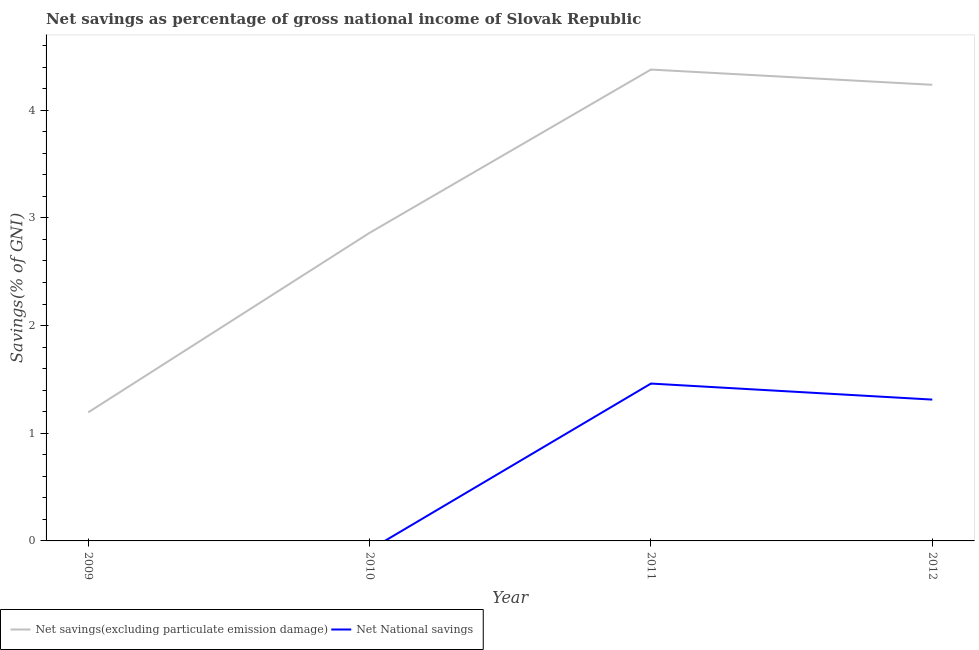What is the net national savings in 2011?
Keep it short and to the point. 1.46. Across all years, what is the maximum net national savings?
Offer a very short reply. 1.46. Across all years, what is the minimum net national savings?
Provide a short and direct response. 0. In which year was the net national savings maximum?
Your answer should be very brief. 2011. What is the total net savings(excluding particulate emission damage) in the graph?
Provide a succinct answer. 12.67. What is the difference between the net savings(excluding particulate emission damage) in 2011 and that in 2012?
Offer a very short reply. 0.14. What is the difference between the net national savings in 2011 and the net savings(excluding particulate emission damage) in 2009?
Your response must be concise. 0.27. What is the average net national savings per year?
Provide a succinct answer. 0.69. In the year 2011, what is the difference between the net savings(excluding particulate emission damage) and net national savings?
Your answer should be very brief. 2.92. In how many years, is the net national savings greater than 3.2 %?
Offer a very short reply. 0. What is the ratio of the net savings(excluding particulate emission damage) in 2009 to that in 2010?
Provide a succinct answer. 0.42. What is the difference between the highest and the second highest net savings(excluding particulate emission damage)?
Your response must be concise. 0.14. What is the difference between the highest and the lowest net savings(excluding particulate emission damage)?
Ensure brevity in your answer.  3.18. In how many years, is the net savings(excluding particulate emission damage) greater than the average net savings(excluding particulate emission damage) taken over all years?
Provide a succinct answer. 2. Is the net savings(excluding particulate emission damage) strictly greater than the net national savings over the years?
Ensure brevity in your answer.  Yes. Is the net national savings strictly less than the net savings(excluding particulate emission damage) over the years?
Give a very brief answer. Yes. What is the difference between two consecutive major ticks on the Y-axis?
Offer a terse response. 1. Are the values on the major ticks of Y-axis written in scientific E-notation?
Keep it short and to the point. No. Does the graph contain any zero values?
Keep it short and to the point. Yes. Does the graph contain grids?
Your answer should be very brief. No. How many legend labels are there?
Make the answer very short. 2. What is the title of the graph?
Your answer should be compact. Net savings as percentage of gross national income of Slovak Republic. Does "Pregnant women" appear as one of the legend labels in the graph?
Keep it short and to the point. No. What is the label or title of the X-axis?
Your answer should be very brief. Year. What is the label or title of the Y-axis?
Give a very brief answer. Savings(% of GNI). What is the Savings(% of GNI) of Net savings(excluding particulate emission damage) in 2009?
Provide a short and direct response. 1.19. What is the Savings(% of GNI) in Net National savings in 2009?
Make the answer very short. 0. What is the Savings(% of GNI) in Net savings(excluding particulate emission damage) in 2010?
Your response must be concise. 2.86. What is the Savings(% of GNI) of Net savings(excluding particulate emission damage) in 2011?
Make the answer very short. 4.38. What is the Savings(% of GNI) of Net National savings in 2011?
Provide a succinct answer. 1.46. What is the Savings(% of GNI) of Net savings(excluding particulate emission damage) in 2012?
Make the answer very short. 4.24. What is the Savings(% of GNI) in Net National savings in 2012?
Offer a terse response. 1.31. Across all years, what is the maximum Savings(% of GNI) in Net savings(excluding particulate emission damage)?
Ensure brevity in your answer.  4.38. Across all years, what is the maximum Savings(% of GNI) in Net National savings?
Provide a short and direct response. 1.46. Across all years, what is the minimum Savings(% of GNI) in Net savings(excluding particulate emission damage)?
Keep it short and to the point. 1.19. What is the total Savings(% of GNI) of Net savings(excluding particulate emission damage) in the graph?
Offer a very short reply. 12.67. What is the total Savings(% of GNI) of Net National savings in the graph?
Provide a short and direct response. 2.77. What is the difference between the Savings(% of GNI) of Net savings(excluding particulate emission damage) in 2009 and that in 2010?
Provide a short and direct response. -1.67. What is the difference between the Savings(% of GNI) in Net savings(excluding particulate emission damage) in 2009 and that in 2011?
Make the answer very short. -3.18. What is the difference between the Savings(% of GNI) in Net savings(excluding particulate emission damage) in 2009 and that in 2012?
Your answer should be very brief. -3.04. What is the difference between the Savings(% of GNI) of Net savings(excluding particulate emission damage) in 2010 and that in 2011?
Your answer should be compact. -1.52. What is the difference between the Savings(% of GNI) of Net savings(excluding particulate emission damage) in 2010 and that in 2012?
Provide a short and direct response. -1.37. What is the difference between the Savings(% of GNI) in Net savings(excluding particulate emission damage) in 2011 and that in 2012?
Offer a terse response. 0.14. What is the difference between the Savings(% of GNI) in Net National savings in 2011 and that in 2012?
Keep it short and to the point. 0.15. What is the difference between the Savings(% of GNI) in Net savings(excluding particulate emission damage) in 2009 and the Savings(% of GNI) in Net National savings in 2011?
Provide a succinct answer. -0.27. What is the difference between the Savings(% of GNI) in Net savings(excluding particulate emission damage) in 2009 and the Savings(% of GNI) in Net National savings in 2012?
Ensure brevity in your answer.  -0.12. What is the difference between the Savings(% of GNI) of Net savings(excluding particulate emission damage) in 2010 and the Savings(% of GNI) of Net National savings in 2011?
Offer a terse response. 1.4. What is the difference between the Savings(% of GNI) in Net savings(excluding particulate emission damage) in 2010 and the Savings(% of GNI) in Net National savings in 2012?
Ensure brevity in your answer.  1.55. What is the difference between the Savings(% of GNI) of Net savings(excluding particulate emission damage) in 2011 and the Savings(% of GNI) of Net National savings in 2012?
Make the answer very short. 3.07. What is the average Savings(% of GNI) of Net savings(excluding particulate emission damage) per year?
Your response must be concise. 3.17. What is the average Savings(% of GNI) in Net National savings per year?
Make the answer very short. 0.69. In the year 2011, what is the difference between the Savings(% of GNI) in Net savings(excluding particulate emission damage) and Savings(% of GNI) in Net National savings?
Keep it short and to the point. 2.92. In the year 2012, what is the difference between the Savings(% of GNI) in Net savings(excluding particulate emission damage) and Savings(% of GNI) in Net National savings?
Make the answer very short. 2.92. What is the ratio of the Savings(% of GNI) of Net savings(excluding particulate emission damage) in 2009 to that in 2010?
Provide a succinct answer. 0.42. What is the ratio of the Savings(% of GNI) of Net savings(excluding particulate emission damage) in 2009 to that in 2011?
Your response must be concise. 0.27. What is the ratio of the Savings(% of GNI) of Net savings(excluding particulate emission damage) in 2009 to that in 2012?
Ensure brevity in your answer.  0.28. What is the ratio of the Savings(% of GNI) of Net savings(excluding particulate emission damage) in 2010 to that in 2011?
Offer a very short reply. 0.65. What is the ratio of the Savings(% of GNI) of Net savings(excluding particulate emission damage) in 2010 to that in 2012?
Ensure brevity in your answer.  0.68. What is the ratio of the Savings(% of GNI) of Net savings(excluding particulate emission damage) in 2011 to that in 2012?
Your response must be concise. 1.03. What is the ratio of the Savings(% of GNI) of Net National savings in 2011 to that in 2012?
Your response must be concise. 1.11. What is the difference between the highest and the second highest Savings(% of GNI) in Net savings(excluding particulate emission damage)?
Make the answer very short. 0.14. What is the difference between the highest and the lowest Savings(% of GNI) in Net savings(excluding particulate emission damage)?
Your answer should be compact. 3.18. What is the difference between the highest and the lowest Savings(% of GNI) of Net National savings?
Make the answer very short. 1.46. 